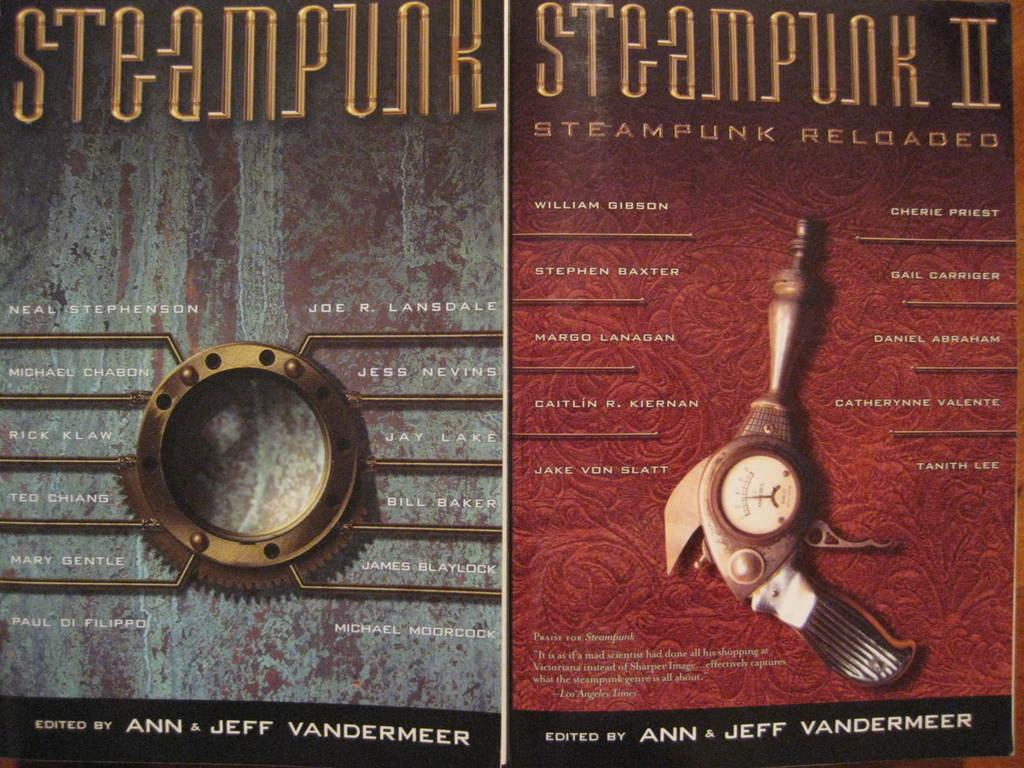<image>
Give a short and clear explanation of the subsequent image. Covers for the books Steampunk and Steampunk II 